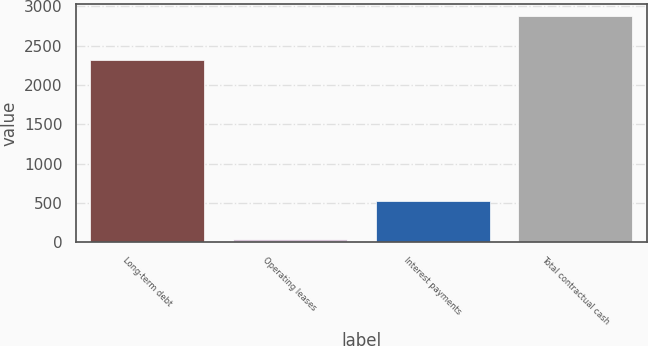Convert chart. <chart><loc_0><loc_0><loc_500><loc_500><bar_chart><fcel>Long-term debt<fcel>Operating leases<fcel>Interest payments<fcel>Total contractual cash<nl><fcel>2317<fcel>33.7<fcel>528.6<fcel>2879.3<nl></chart> 